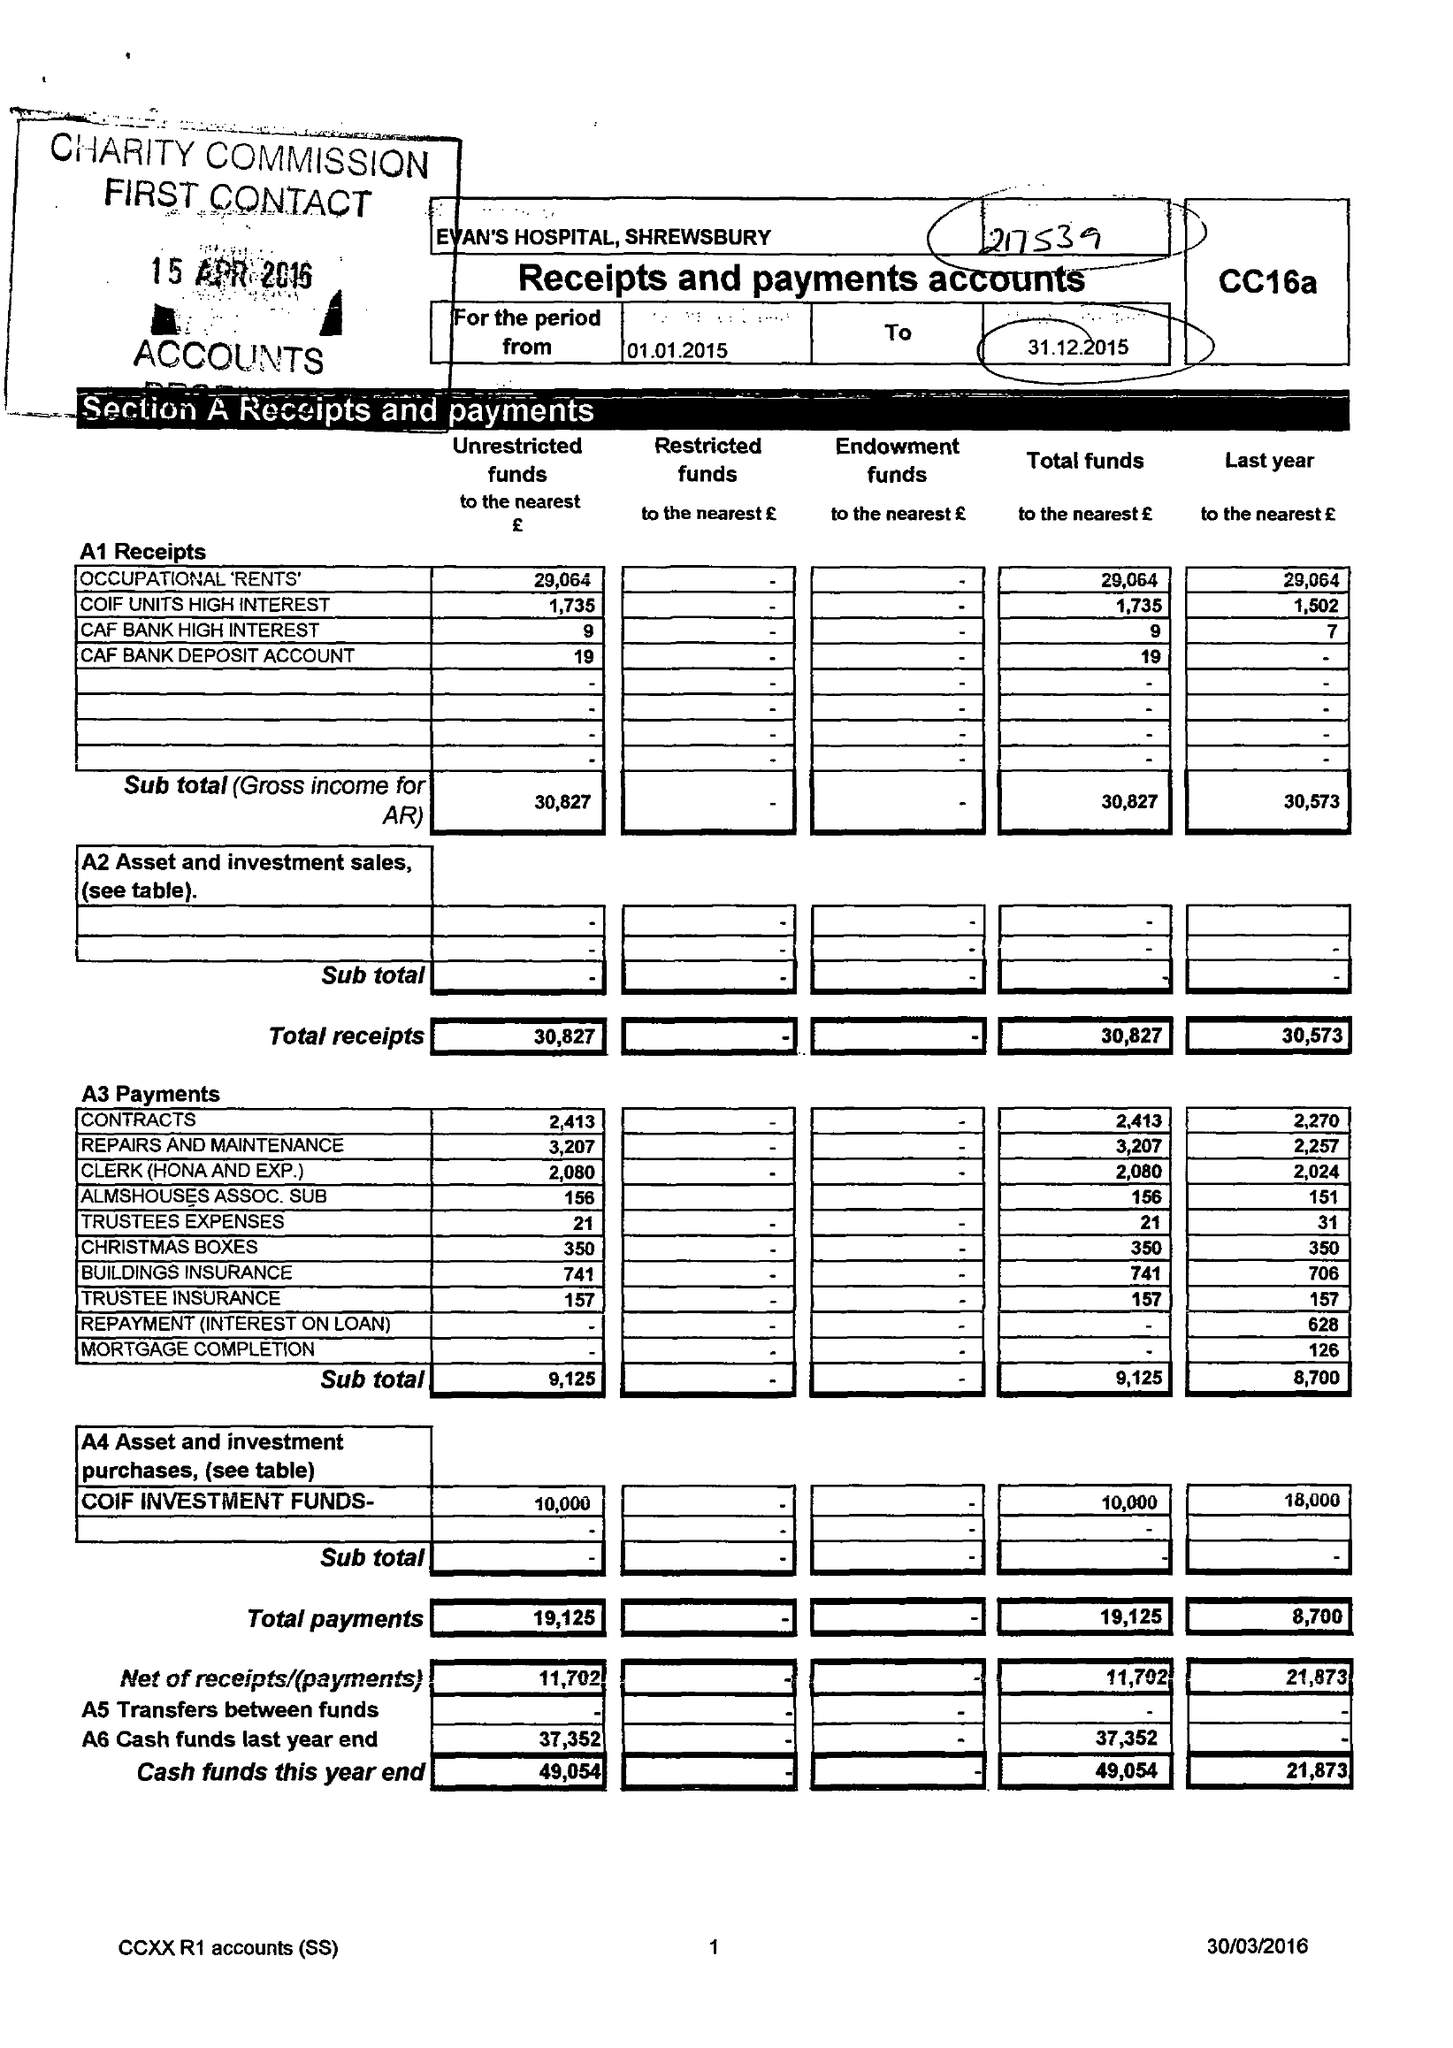What is the value for the report_date?
Answer the question using a single word or phrase. 2015-12-31 